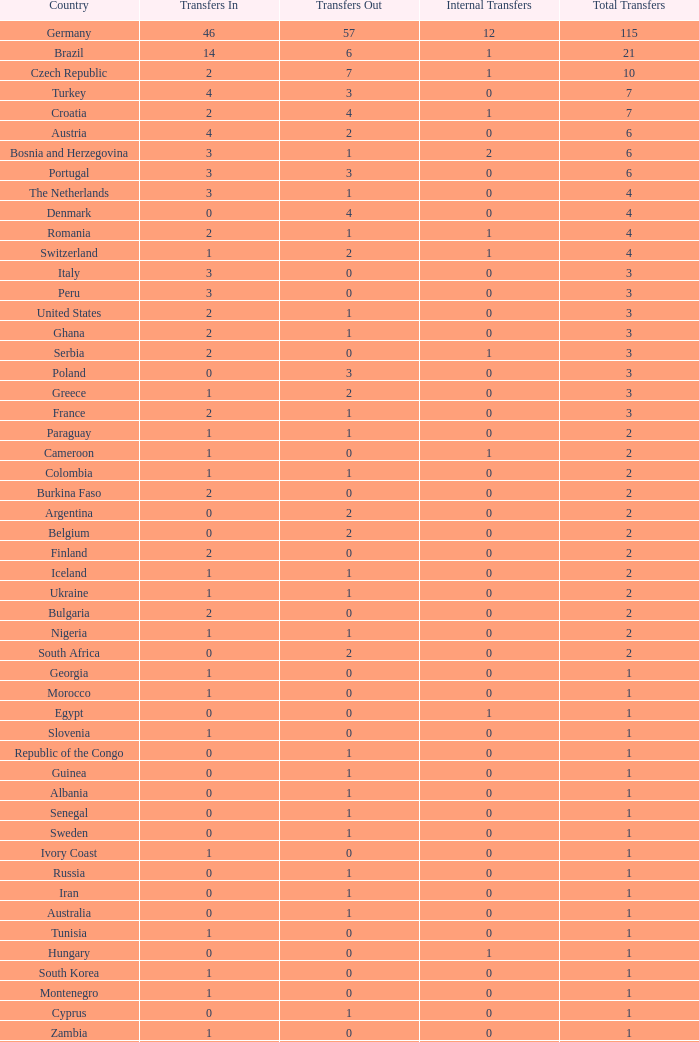What are the transfers in for magyarorszag? 0.0. 